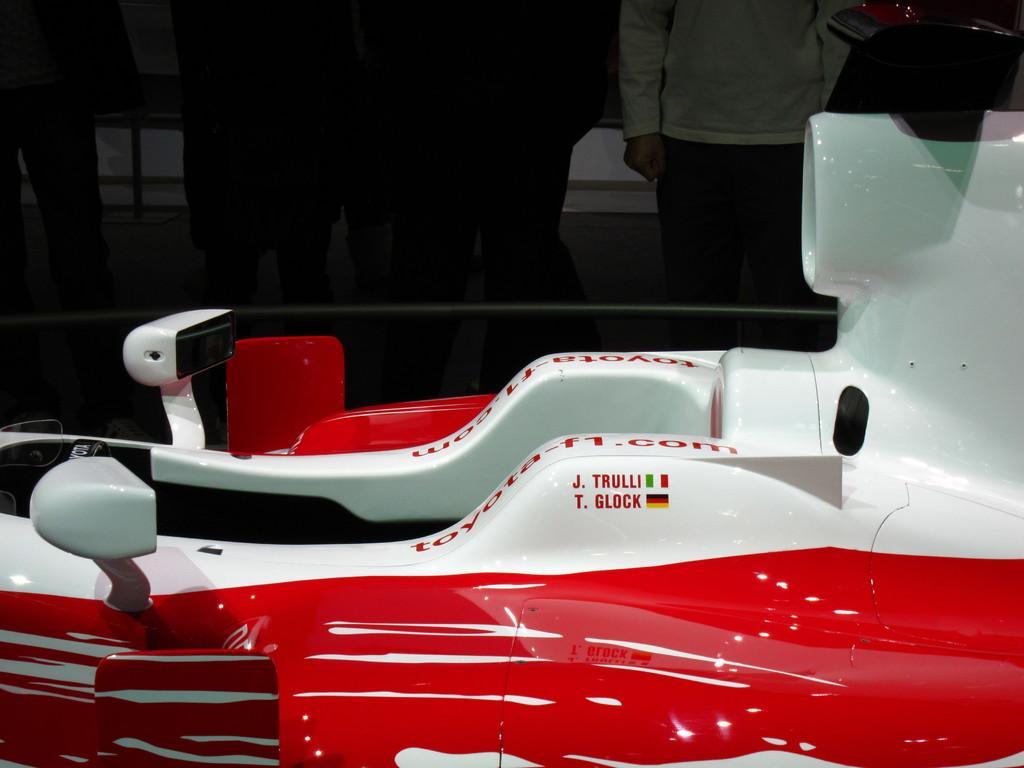Can you describe this image briefly? In this picture I can see a red and white color object. in the background I can see people are standing. On the object I can see something written on it. 